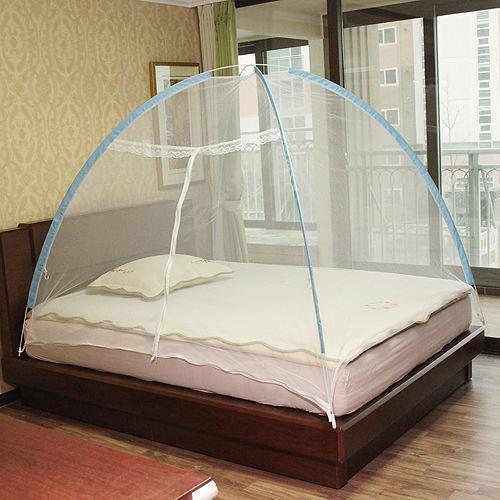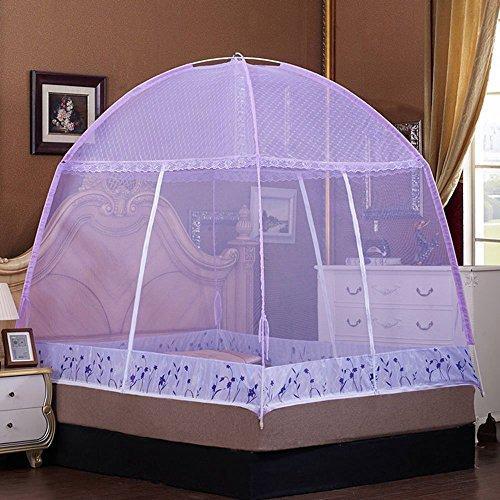The first image is the image on the left, the second image is the image on the right. For the images shown, is this caption "There is artwork on the wall behind the bed in the right image." true? Answer yes or no. Yes. The first image is the image on the left, the second image is the image on the right. Evaluate the accuracy of this statement regarding the images: "A bed canopy has a checkered fabric strip around the bottom.". Is it true? Answer yes or no. No. 